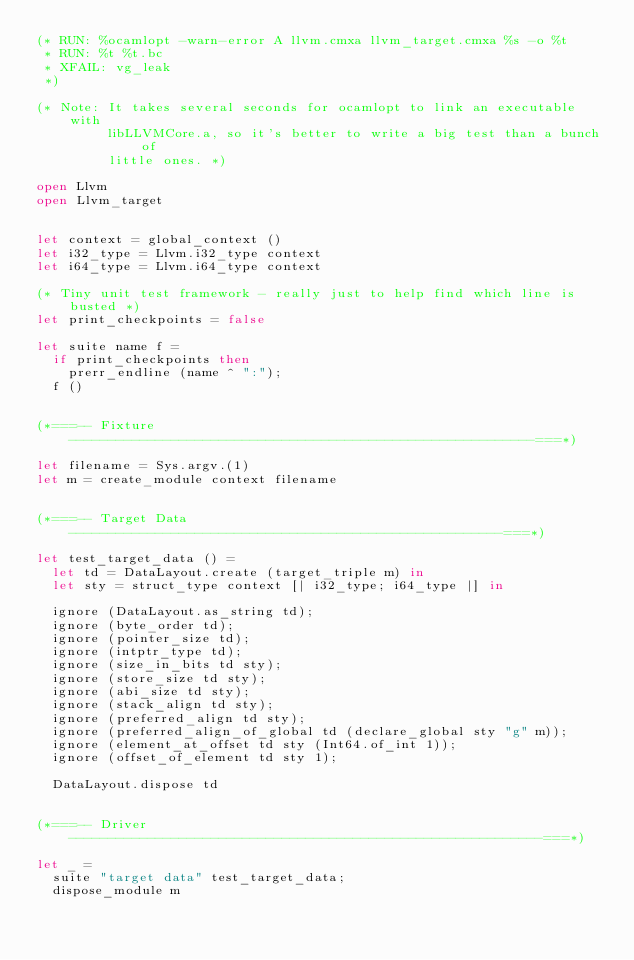Convert code to text. <code><loc_0><loc_0><loc_500><loc_500><_OCaml_>(* RUN: %ocamlopt -warn-error A llvm.cmxa llvm_target.cmxa %s -o %t
 * RUN: %t %t.bc
 * XFAIL: vg_leak
 *)

(* Note: It takes several seconds for ocamlopt to link an executable with
         libLLVMCore.a, so it's better to write a big test than a bunch of
         little ones. *)

open Llvm
open Llvm_target


let context = global_context ()
let i32_type = Llvm.i32_type context
let i64_type = Llvm.i64_type context

(* Tiny unit test framework - really just to help find which line is busted *)
let print_checkpoints = false

let suite name f =
  if print_checkpoints then
    prerr_endline (name ^ ":");
  f ()


(*===-- Fixture -----------------------------------------------------------===*)

let filename = Sys.argv.(1)
let m = create_module context filename


(*===-- Target Data -------------------------------------------------------===*)

let test_target_data () =
  let td = DataLayout.create (target_triple m) in
  let sty = struct_type context [| i32_type; i64_type |] in
  
  ignore (DataLayout.as_string td);
  ignore (byte_order td);
  ignore (pointer_size td);
  ignore (intptr_type td);
  ignore (size_in_bits td sty);
  ignore (store_size td sty);
  ignore (abi_size td sty);
  ignore (stack_align td sty);
  ignore (preferred_align td sty);
  ignore (preferred_align_of_global td (declare_global sty "g" m));
  ignore (element_at_offset td sty (Int64.of_int 1));
  ignore (offset_of_element td sty 1);
  
  DataLayout.dispose td


(*===-- Driver ------------------------------------------------------------===*)

let _ =
  suite "target data" test_target_data;
  dispose_module m
</code> 